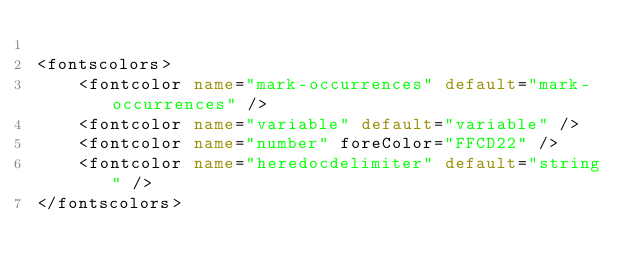<code> <loc_0><loc_0><loc_500><loc_500><_XML_>
<fontscolors>
    <fontcolor name="mark-occurrences" default="mark-occurrences" />
	<fontcolor name="variable" default="variable" />
	<fontcolor name="number" foreColor="FFCD22" />
	<fontcolor name="heredocdelimiter" default="string" />
</fontscolors>
</code> 